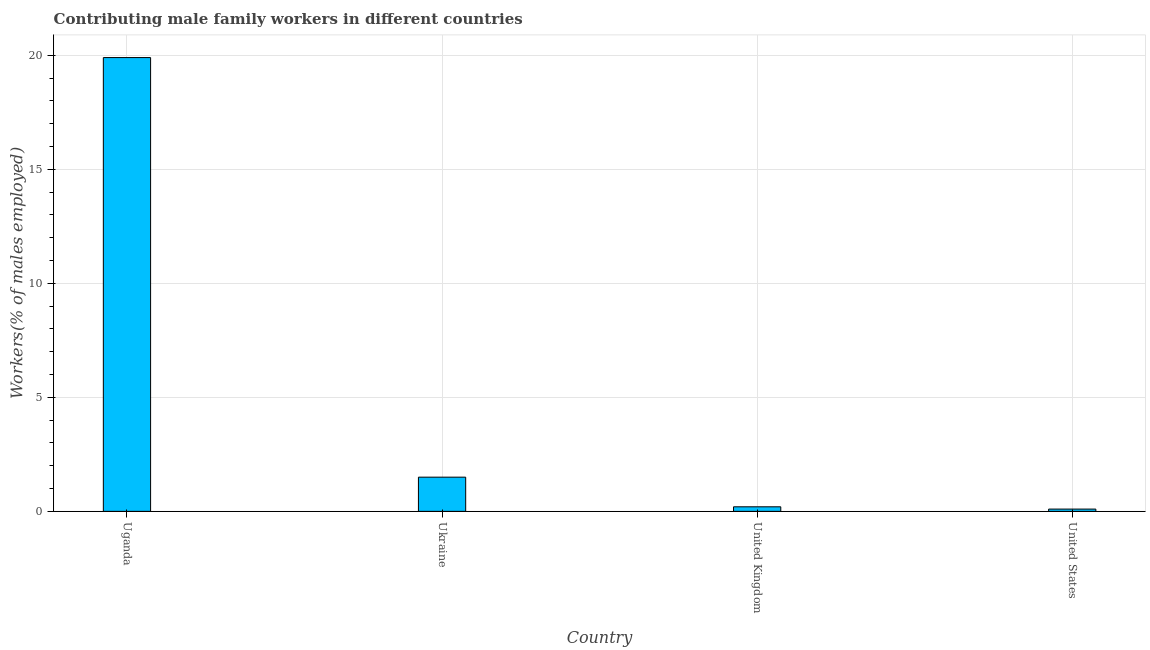Does the graph contain grids?
Give a very brief answer. Yes. What is the title of the graph?
Make the answer very short. Contributing male family workers in different countries. What is the label or title of the Y-axis?
Give a very brief answer. Workers(% of males employed). What is the contributing male family workers in Uganda?
Keep it short and to the point. 19.9. Across all countries, what is the maximum contributing male family workers?
Keep it short and to the point. 19.9. Across all countries, what is the minimum contributing male family workers?
Ensure brevity in your answer.  0.1. In which country was the contributing male family workers maximum?
Give a very brief answer. Uganda. What is the sum of the contributing male family workers?
Give a very brief answer. 21.7. What is the difference between the contributing male family workers in Uganda and United Kingdom?
Give a very brief answer. 19.7. What is the average contributing male family workers per country?
Provide a succinct answer. 5.42. What is the median contributing male family workers?
Offer a very short reply. 0.85. In how many countries, is the contributing male family workers greater than 16 %?
Give a very brief answer. 1. What is the ratio of the contributing male family workers in United Kingdom to that in United States?
Make the answer very short. 2. Is the contributing male family workers in United Kingdom less than that in United States?
Offer a very short reply. No. Is the difference between the contributing male family workers in Uganda and Ukraine greater than the difference between any two countries?
Your answer should be very brief. No. Is the sum of the contributing male family workers in Uganda and Ukraine greater than the maximum contributing male family workers across all countries?
Offer a very short reply. Yes. What is the difference between the highest and the lowest contributing male family workers?
Provide a succinct answer. 19.8. Are all the bars in the graph horizontal?
Your answer should be very brief. No. How many countries are there in the graph?
Your answer should be compact. 4. What is the Workers(% of males employed) in Uganda?
Your answer should be compact. 19.9. What is the Workers(% of males employed) of Ukraine?
Offer a very short reply. 1.5. What is the Workers(% of males employed) of United Kingdom?
Make the answer very short. 0.2. What is the Workers(% of males employed) of United States?
Offer a very short reply. 0.1. What is the difference between the Workers(% of males employed) in Uganda and United Kingdom?
Offer a terse response. 19.7. What is the difference between the Workers(% of males employed) in Uganda and United States?
Your response must be concise. 19.8. What is the difference between the Workers(% of males employed) in Ukraine and United Kingdom?
Make the answer very short. 1.3. What is the ratio of the Workers(% of males employed) in Uganda to that in Ukraine?
Make the answer very short. 13.27. What is the ratio of the Workers(% of males employed) in Uganda to that in United Kingdom?
Your answer should be compact. 99.5. What is the ratio of the Workers(% of males employed) in Uganda to that in United States?
Keep it short and to the point. 199. What is the ratio of the Workers(% of males employed) in Ukraine to that in United Kingdom?
Ensure brevity in your answer.  7.5. What is the ratio of the Workers(% of males employed) in United Kingdom to that in United States?
Provide a short and direct response. 2. 